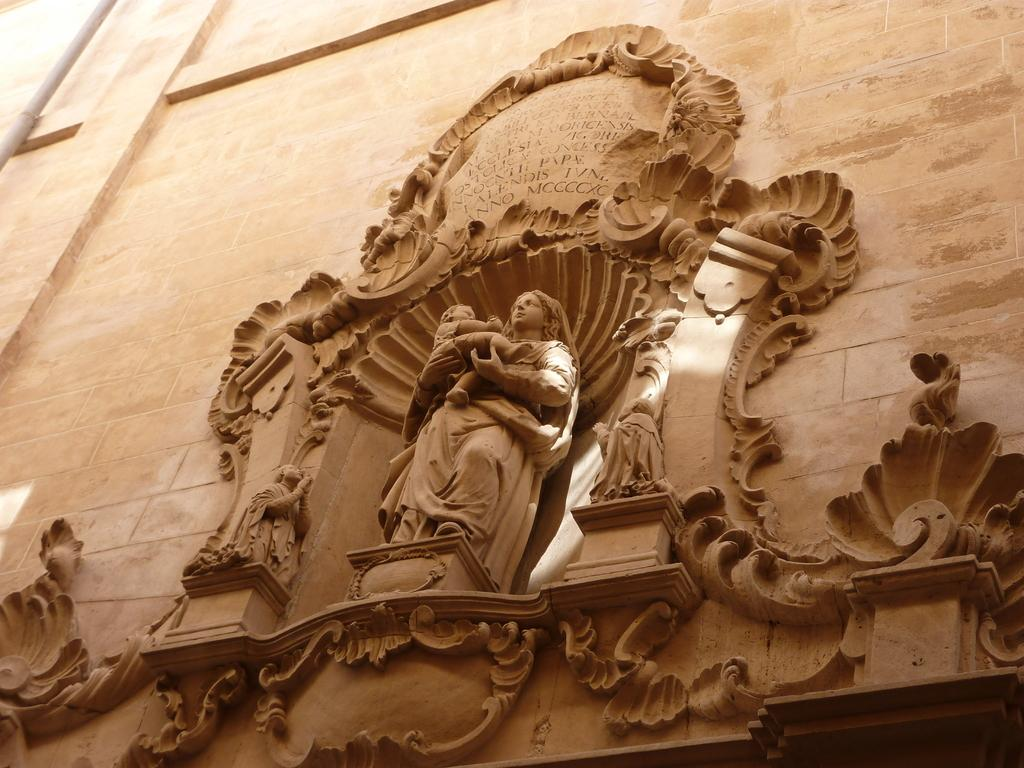What is the main subject of the image? The main subject of the image is a statue of a woman holding a baby. Can you describe the statue in more detail? The statue depicts a woman holding a baby. What is written or depicted at the top of the wall in the image? There is text at the top of the wall in the image. How many basketballs can be seen in the image? There are no basketballs present in the image. What type of leg is visible on the statue in the image? The statue is of a woman holding a baby, and there are no legs visible in the image. 